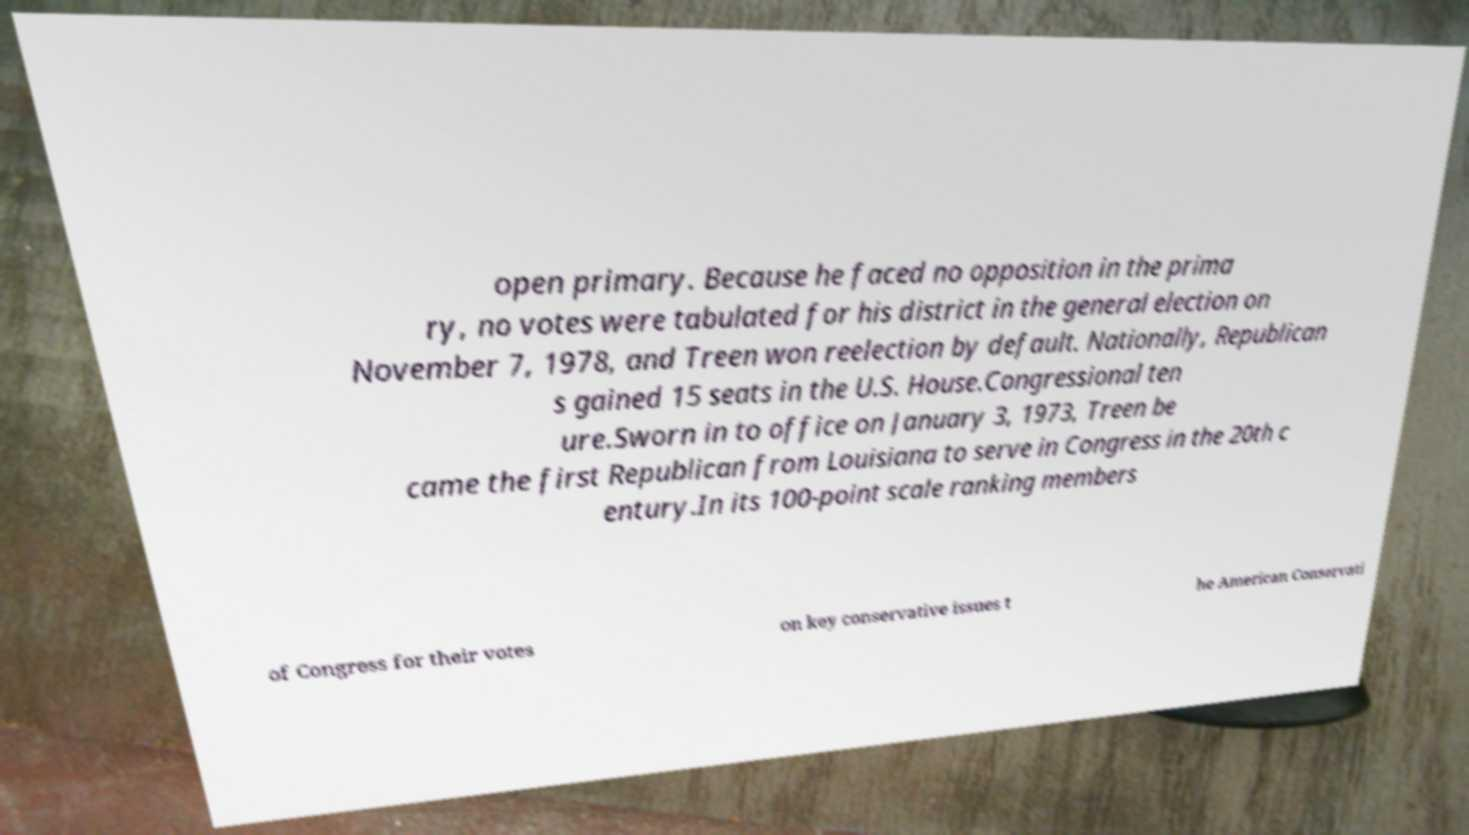Could you extract and type out the text from this image? open primary. Because he faced no opposition in the prima ry, no votes were tabulated for his district in the general election on November 7, 1978, and Treen won reelection by default. Nationally, Republican s gained 15 seats in the U.S. House.Congressional ten ure.Sworn in to office on January 3, 1973, Treen be came the first Republican from Louisiana to serve in Congress in the 20th c entury.In its 100-point scale ranking members of Congress for their votes on key conservative issues t he American Conservati 